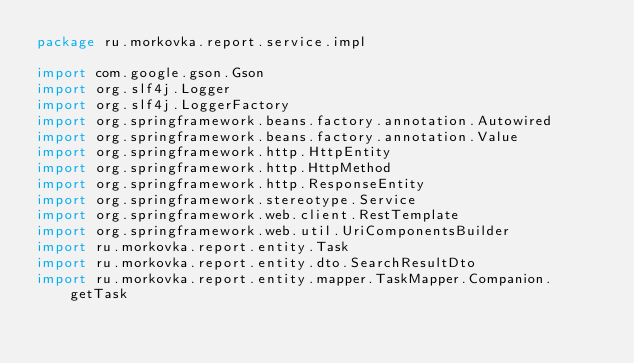Convert code to text. <code><loc_0><loc_0><loc_500><loc_500><_Kotlin_>package ru.morkovka.report.service.impl

import com.google.gson.Gson
import org.slf4j.Logger
import org.slf4j.LoggerFactory
import org.springframework.beans.factory.annotation.Autowired
import org.springframework.beans.factory.annotation.Value
import org.springframework.http.HttpEntity
import org.springframework.http.HttpMethod
import org.springframework.http.ResponseEntity
import org.springframework.stereotype.Service
import org.springframework.web.client.RestTemplate
import org.springframework.web.util.UriComponentsBuilder
import ru.morkovka.report.entity.Task
import ru.morkovka.report.entity.dto.SearchResultDto
import ru.morkovka.report.entity.mapper.TaskMapper.Companion.getTask</code> 